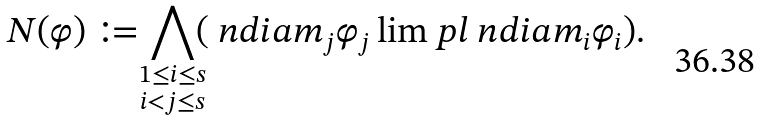<formula> <loc_0><loc_0><loc_500><loc_500>N ( \varphi ) \coloneqq \bigwedge _ { \mathclap { \substack { 1 \leq i \leq s \\ i < j \leq s } } } ( \ n d i a { m _ { j } } \varphi _ { j } \lim p l \ n d i a { m _ { i } } \varphi _ { i } ) .</formula> 